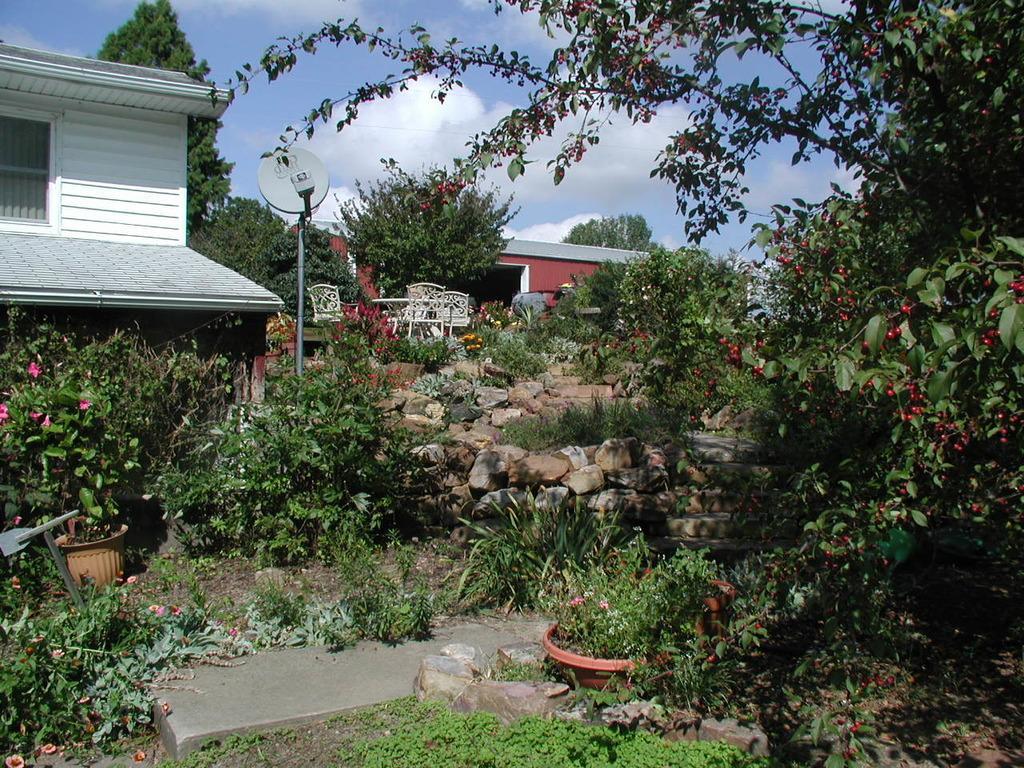How would you summarize this image in a sentence or two? In this image we can see some plants, flower pots, stones, there are some houses and in the background of the image there are some trees and clear sky. 